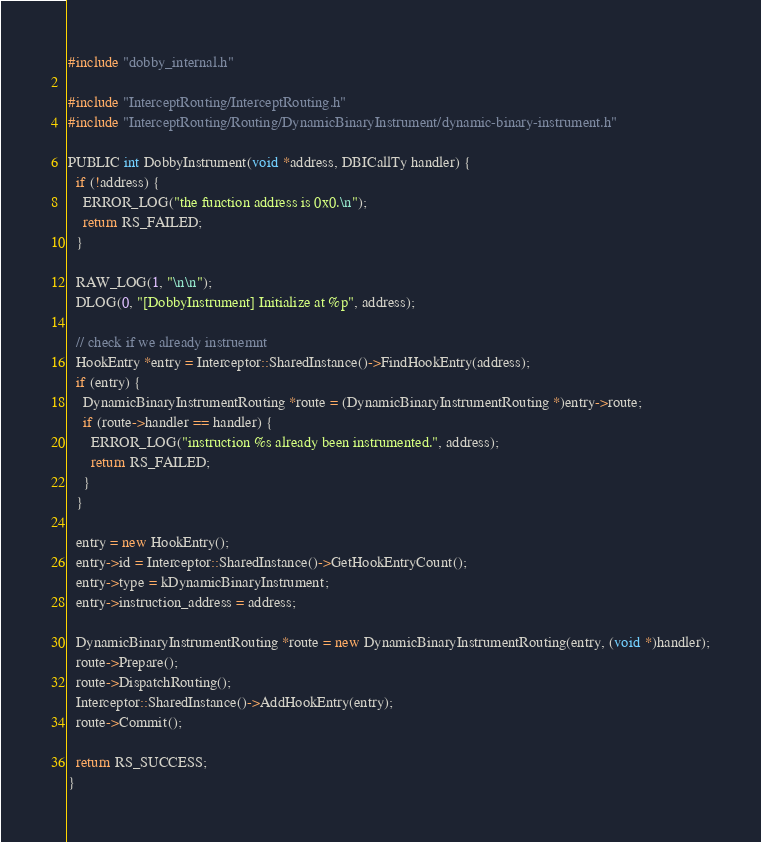Convert code to text. <code><loc_0><loc_0><loc_500><loc_500><_C++_>#include "dobby_internal.h"

#include "InterceptRouting/InterceptRouting.h"
#include "InterceptRouting/Routing/DynamicBinaryInstrument/dynamic-binary-instrument.h"

PUBLIC int DobbyInstrument(void *address, DBICallTy handler) {
  if (!address) {
    ERROR_LOG("the function address is 0x0.\n");
    return RS_FAILED;
  }

  RAW_LOG(1, "\n\n");
  DLOG(0, "[DobbyInstrument] Initialize at %p", address);

  // check if we already instruemnt
  HookEntry *entry = Interceptor::SharedInstance()->FindHookEntry(address);
  if (entry) {
    DynamicBinaryInstrumentRouting *route = (DynamicBinaryInstrumentRouting *)entry->route;
    if (route->handler == handler) {
      ERROR_LOG("instruction %s already been instrumented.", address);
      return RS_FAILED;
    }
  }

  entry = new HookEntry();
  entry->id = Interceptor::SharedInstance()->GetHookEntryCount();
  entry->type = kDynamicBinaryInstrument;
  entry->instruction_address = address;

  DynamicBinaryInstrumentRouting *route = new DynamicBinaryInstrumentRouting(entry, (void *)handler);
  route->Prepare();
  route->DispatchRouting();
  Interceptor::SharedInstance()->AddHookEntry(entry);
  route->Commit();

  return RS_SUCCESS;
}
</code> 